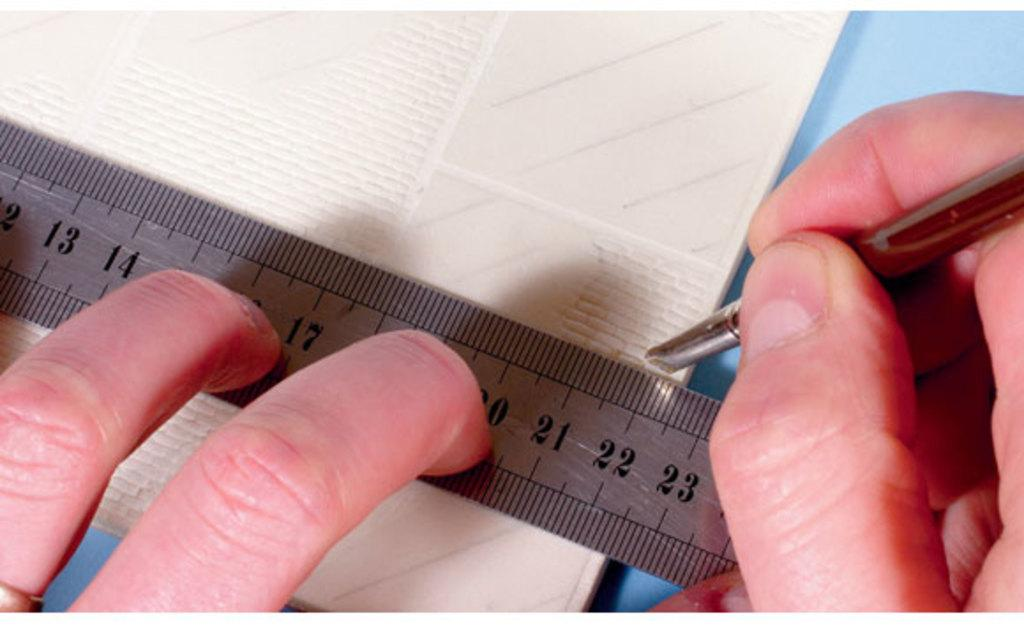What part of the human body is visible in the image? A human hand is visible in the image. What is the hand doing in the image? The fingers of the hand are holding an object. What tool is present in the image for measuring or comparing sizes? There is a measuring scale in the image. What is the background color of the measuring scale? The measuring scale is on a white object. What color can be seen in the image besides white? The color blue is present in the image. How does the wheel in the image affect the smell of the object being held by the hand? There is no wheel present in the image, so it cannot affect the smell of the object being held by the hand. 